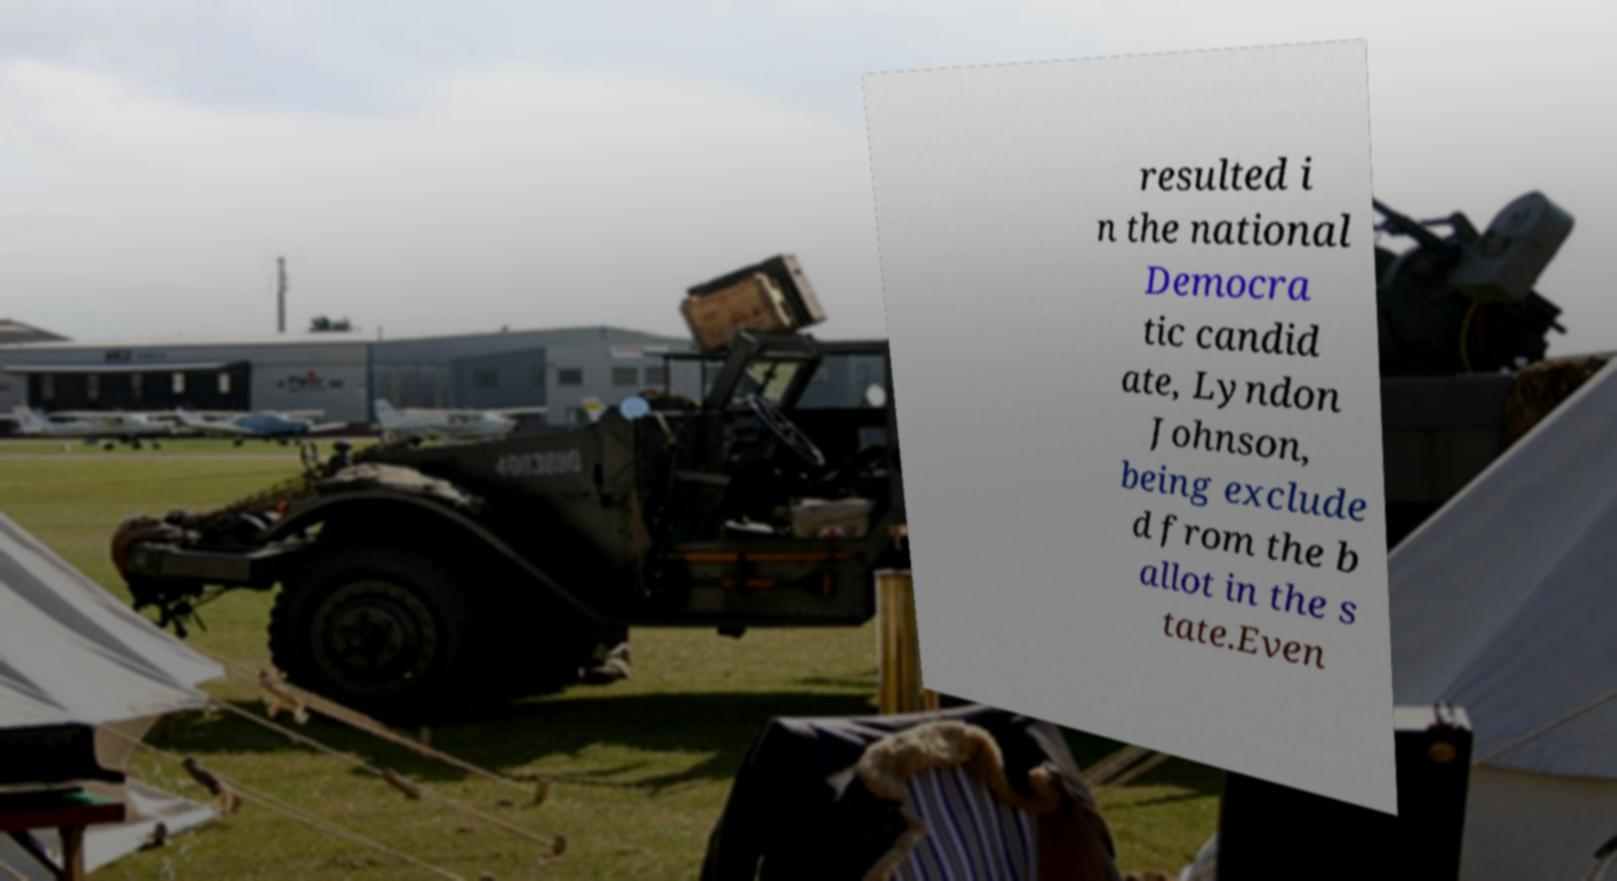Please read and relay the text visible in this image. What does it say? resulted i n the national Democra tic candid ate, Lyndon Johnson, being exclude d from the b allot in the s tate.Even 